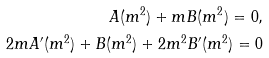<formula> <loc_0><loc_0><loc_500><loc_500>A ( m ^ { 2 } ) + m B ( m ^ { 2 } ) = 0 , \\ 2 m A ^ { \prime } ( m ^ { 2 } ) + B ( m ^ { 2 } ) + 2 m ^ { 2 } B ^ { \prime } ( m ^ { 2 } ) = 0</formula> 